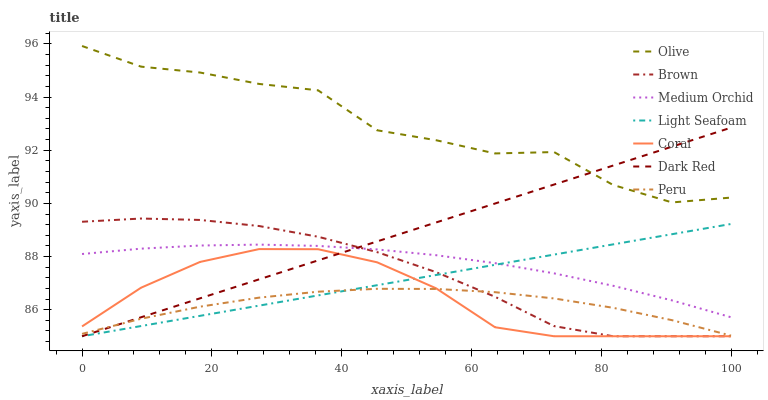Does Dark Red have the minimum area under the curve?
Answer yes or no. No. Does Dark Red have the maximum area under the curve?
Answer yes or no. No. Is Coral the smoothest?
Answer yes or no. No. Is Coral the roughest?
Answer yes or no. No. Does Medium Orchid have the lowest value?
Answer yes or no. No. Does Dark Red have the highest value?
Answer yes or no. No. Is Coral less than Olive?
Answer yes or no. Yes. Is Olive greater than Brown?
Answer yes or no. Yes. Does Coral intersect Olive?
Answer yes or no. No. 